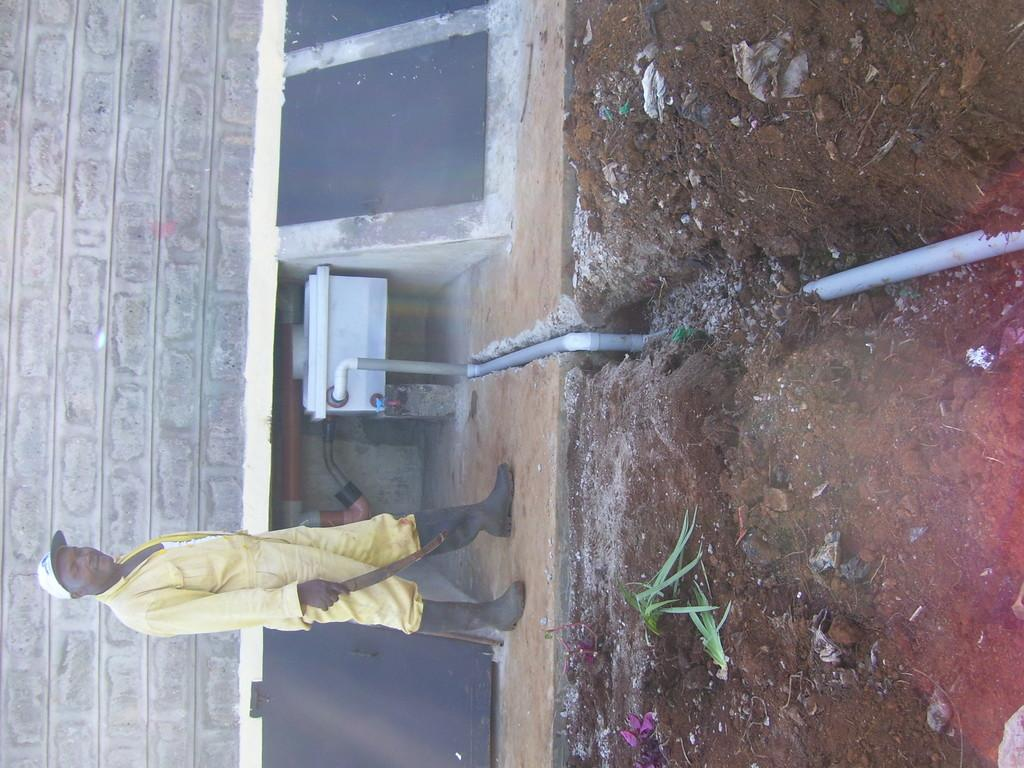What can be seen in the image? There is a person in the image. Can you describe the person's clothing? The person is wearing a white cap and a yellow dress. What is visible behind the person? There is a stonewall and a pipe behind the person. What type of cheese is being used to decorate the top of the person's head in the image? There is no cheese present in the image, and the person's head is not decorated with any cheese. 